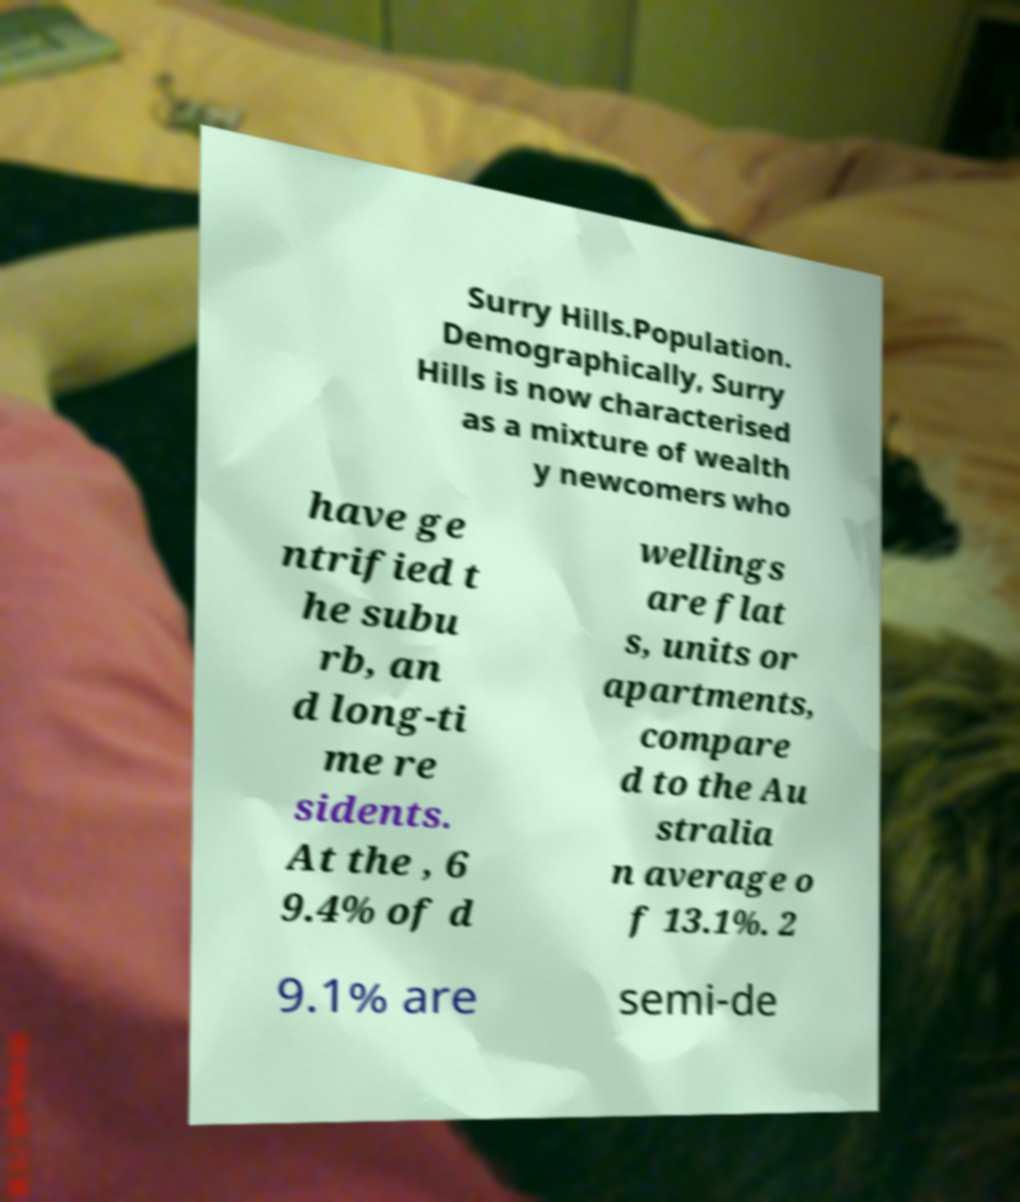Can you accurately transcribe the text from the provided image for me? Surry Hills.Population. Demographically, Surry Hills is now characterised as a mixture of wealth y newcomers who have ge ntrified t he subu rb, an d long-ti me re sidents. At the , 6 9.4% of d wellings are flat s, units or apartments, compare d to the Au stralia n average o f 13.1%. 2 9.1% are semi-de 